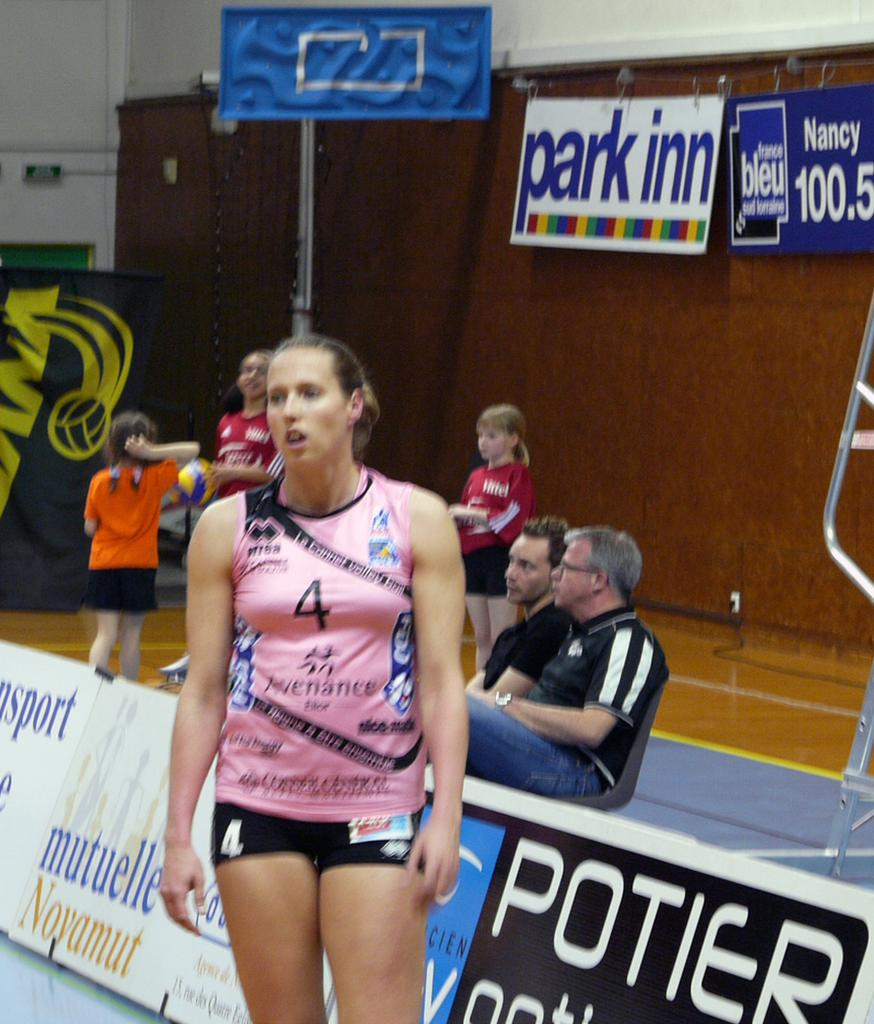<image>
Present a compact description of the photo's key features. Girl participating in either baseball or gymnastics, she is # 4. 